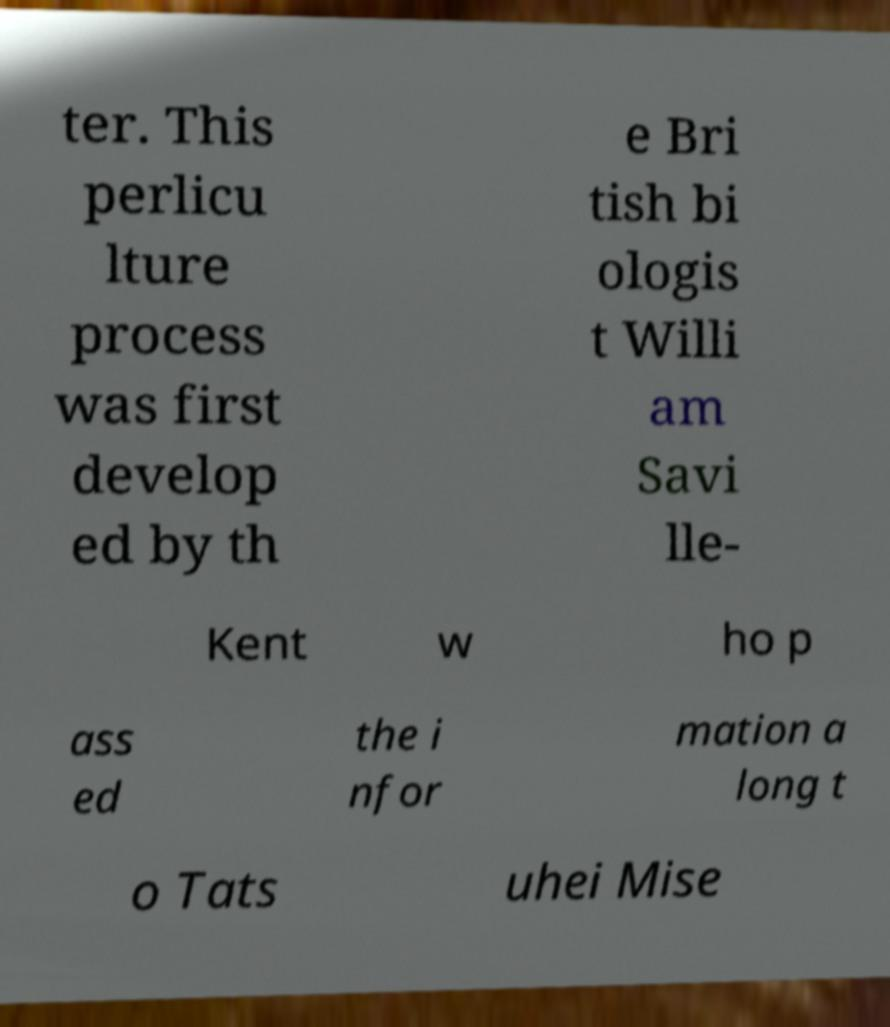Can you accurately transcribe the text from the provided image for me? ter. This perlicu lture process was first develop ed by th e Bri tish bi ologis t Willi am Savi lle- Kent w ho p ass ed the i nfor mation a long t o Tats uhei Mise 